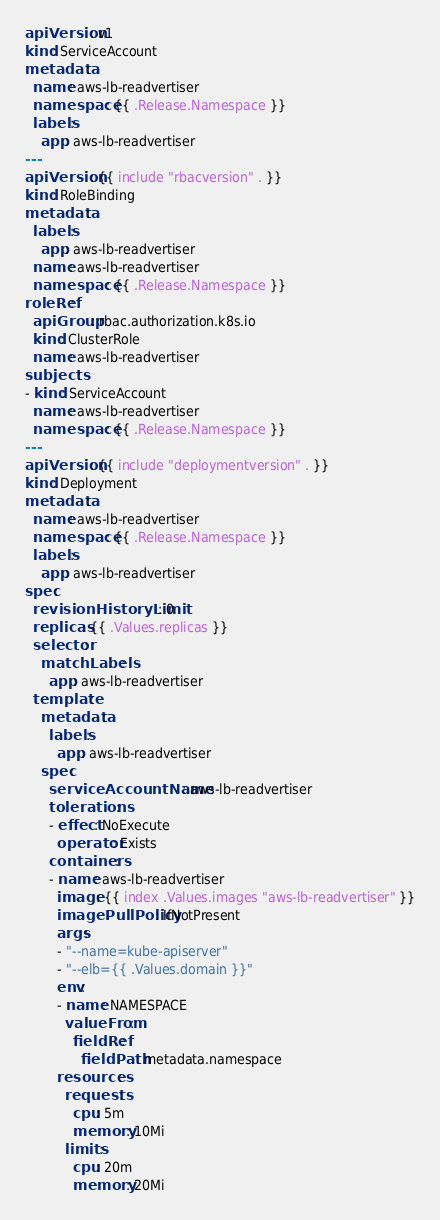<code> <loc_0><loc_0><loc_500><loc_500><_YAML_>apiVersion: v1
kind: ServiceAccount
metadata:
  name: aws-lb-readvertiser
  namespace: {{ .Release.Namespace }}
  labels:
    app: aws-lb-readvertiser
---
apiVersion: {{ include "rbacversion" . }}
kind: RoleBinding
metadata:
  labels:
    app: aws-lb-readvertiser
  name: aws-lb-readvertiser
  namespace: {{ .Release.Namespace }}
roleRef:
  apiGroup: rbac.authorization.k8s.io
  kind: ClusterRole
  name: aws-lb-readvertiser
subjects:
- kind: ServiceAccount
  name: aws-lb-readvertiser
  namespace: {{ .Release.Namespace }}
---
apiVersion: {{ include "deploymentversion" . }}
kind: Deployment
metadata:
  name: aws-lb-readvertiser
  namespace: {{ .Release.Namespace }}
  labels:
    app: aws-lb-readvertiser
spec:
  revisionHistoryLimit: 0
  replicas: {{ .Values.replicas }}
  selector:
    matchLabels:
      app: aws-lb-readvertiser
  template:
    metadata:
      labels:
        app: aws-lb-readvertiser
    spec:
      serviceAccountName: aws-lb-readvertiser
      tolerations:
      - effect: NoExecute
        operator: Exists
      containers:
      - name: aws-lb-readvertiser
        image: {{ index .Values.images "aws-lb-readvertiser" }}
        imagePullPolicy: IfNotPresent
        args:
        - "--name=kube-apiserver"
        - "--elb={{ .Values.domain }}"
        env:
        - name: NAMESPACE
          valueFrom:
            fieldRef:
              fieldPath: metadata.namespace
        resources:
          requests:
            cpu: 5m
            memory: 10Mi
          limits:
            cpu: 20m
            memory: 20Mi
</code> 